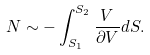<formula> <loc_0><loc_0><loc_500><loc_500>N \sim - \int ^ { S _ { 2 } } _ { S _ { 1 } } \frac { V } { \partial V } d S .</formula> 